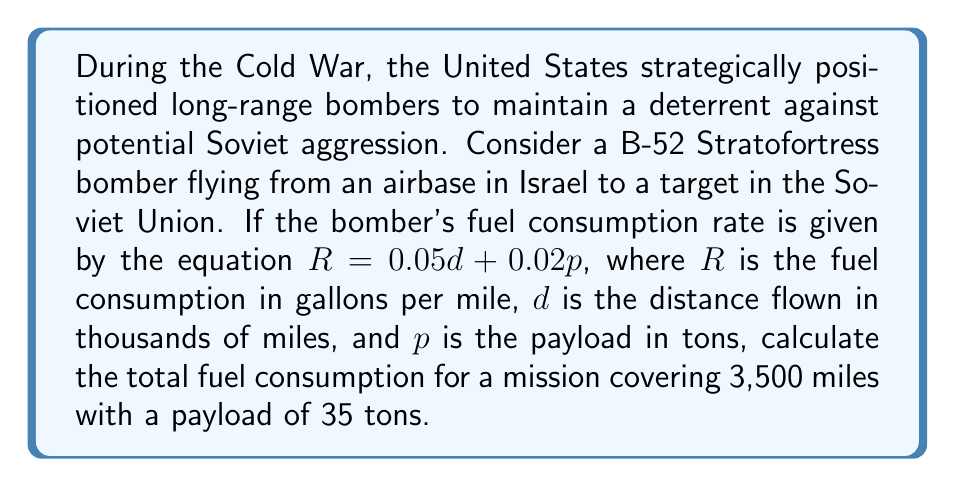Provide a solution to this math problem. To solve this problem, we'll follow these steps:

1. Identify the given information:
   - Distance ($d$) = 3,500 miles = 3.5 thousand miles
   - Payload ($p$) = 35 tons
   - Fuel consumption rate equation: $R = 0.05d + 0.02p$

2. Calculate the fuel consumption rate ($R$):
   $$R = 0.05d + 0.02p$$
   $$R = 0.05(3.5) + 0.02(35)$$
   $$R = 0.175 + 0.7$$
   $$R = 0.875$$ gallons per mile

3. Calculate the total fuel consumption:
   Total fuel consumption = Fuel consumption rate × Total distance
   $$\text{Total fuel} = R \times \text{distance}$$
   $$\text{Total fuel} = 0.875 \times 3,500$$
   $$\text{Total fuel} = 3,062.5$$ gallons

Therefore, the total fuel consumption for the mission is 3,062.5 gallons.
Answer: 3,062.5 gallons 